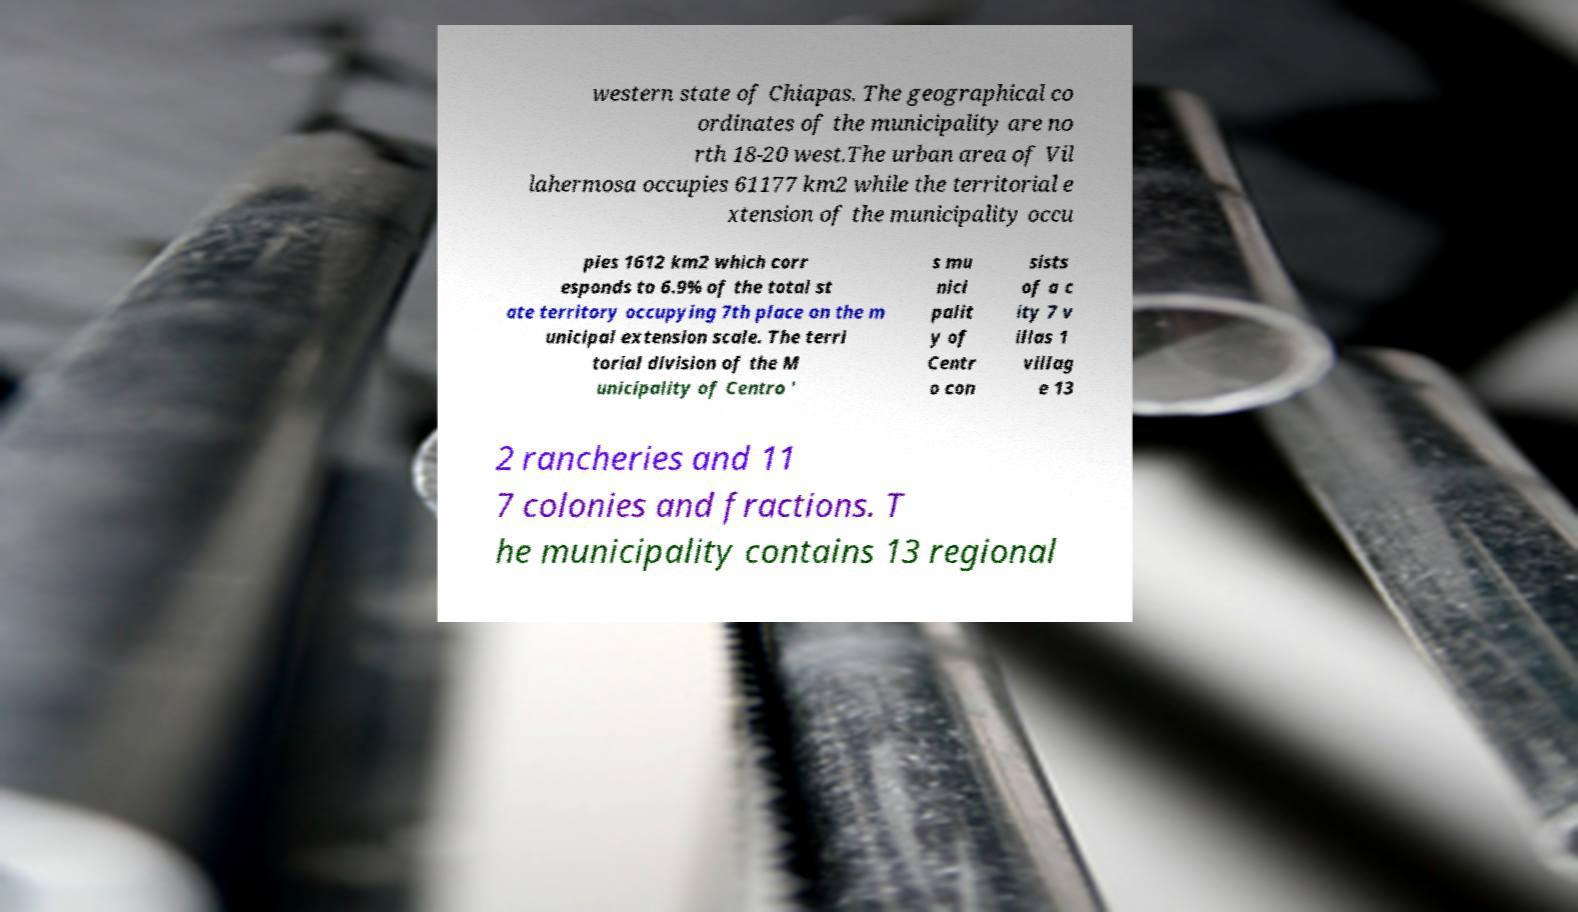Could you assist in decoding the text presented in this image and type it out clearly? western state of Chiapas. The geographical co ordinates of the municipality are no rth 18-20 west.The urban area of Vil lahermosa occupies 61177 km2 while the territorial e xtension of the municipality occu pies 1612 km2 which corr esponds to 6.9% of the total st ate territory occupying 7th place on the m unicipal extension scale. The terri torial division of the M unicipality of Centro ' s mu nici palit y of Centr o con sists of a c ity 7 v illas 1 villag e 13 2 rancheries and 11 7 colonies and fractions. T he municipality contains 13 regional 